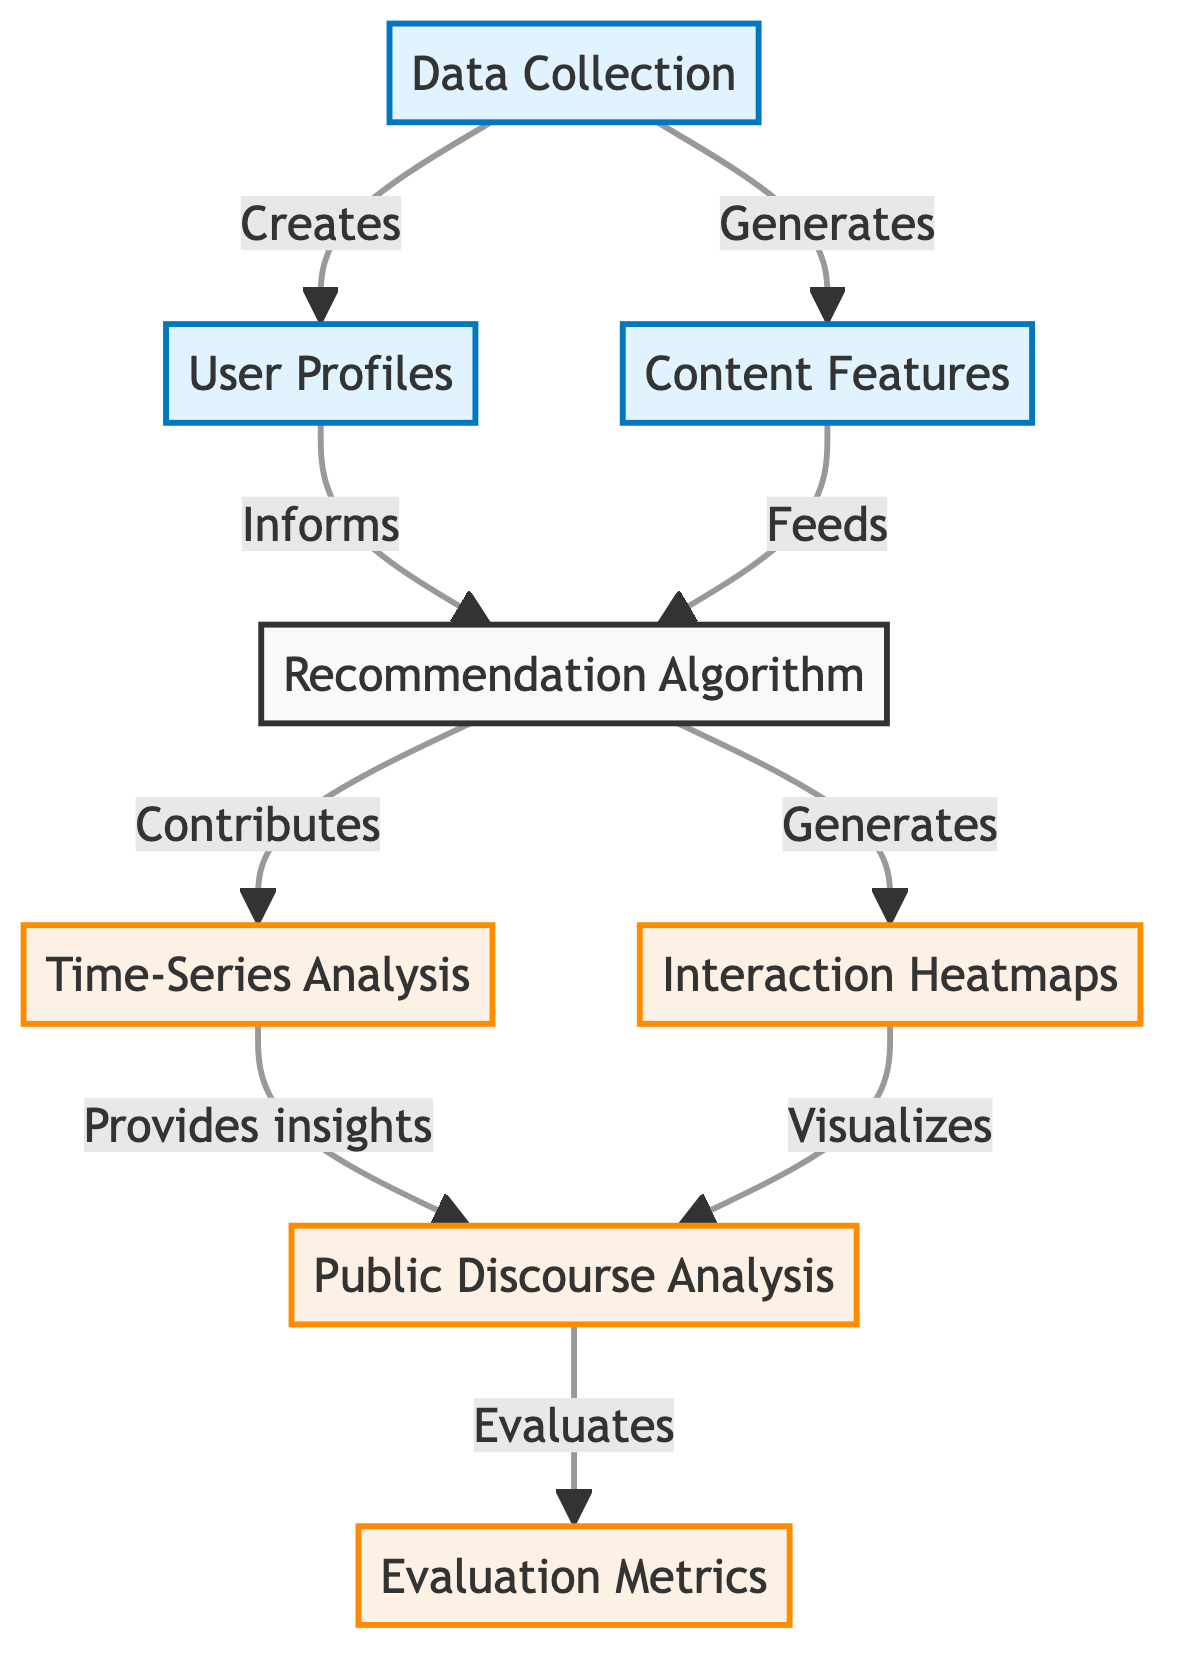What is the first node in the diagram? The first node in the diagram is "Data Collection," which is the starting point of the flowchart.
Answer: Data Collection How many analysis nodes are present in the diagram? The analysis nodes in the diagram are "Time-Series Analysis," "Interaction Heatmaps," "Public Discourse Analysis," and "Evaluation Metrics." Counting these gives a total of four analysis nodes.
Answer: 4 Which node informs the recommendation algorithm? The node that informs the recommendation algorithm is "User Profiles." This is indicated by the directed edge from "User Profiles" to "Recommendation Algorithm."
Answer: User Profiles What does the recommendation algorithm generate? The recommendation algorithm generates "Interaction Heatmaps." This relationship is shown by the directed arrow leading from "Recommendation Algorithm" to "Interaction Heatmaps."
Answer: Interaction Heatmaps How does time-series analysis provide insights? Time-Series Analysis provides insights to "Public Discourse Analysis," as indicated by the directed edge that connects them, showing the flow of information from one to the other.
Answer: Public Discourse Analysis Which nodes are classified as processes in the diagram? The process nodes include "Data Collection," "User Profiles," and "Content Features." These are visually distinct and grouped under the process classification in the diagram.
Answer: Data Collection, User Profiles, Content Features What is the output of the public discourse analysis? The output of the "Public Discourse Analysis" node is the "Evaluation Metrics," which is indicated by the directed edge connecting them.
Answer: Evaluation Metrics How does content features relate to the recommendation algorithm? Content Features feeds into the Recommendation Algorithm, as shown by the directed arrow between "Content Features" and "Recommendation Algorithm."
Answer: Feeds What is the connection between recommendation algorithm and time series analysis? The Recommendation Algorithm contributes to Time-Series Analysis, as indicated by the directed edge flowing from "Recommendation Algorithm" to "Time-Series Analysis."
Answer: Contributes 